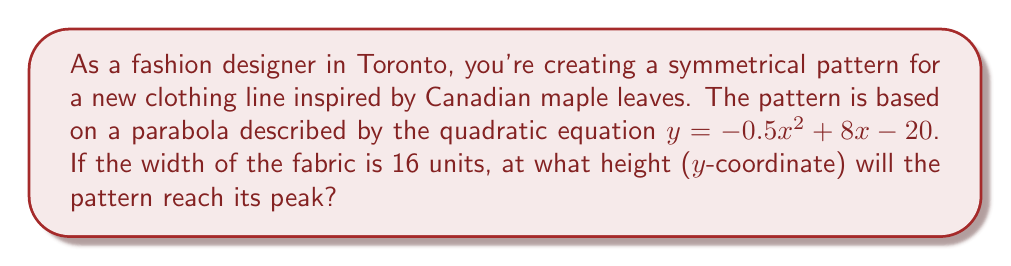Provide a solution to this math problem. To find the peak of the parabola, we need to follow these steps:

1) The quadratic equation is in the form $y = ax^2 + bx + c$, where:
   $a = -0.5$
   $b = 8$
   $c = -20$

2) For a parabola $y = ax^2 + bx + c$, the x-coordinate of the vertex is given by the formula:
   $$x = -\frac{b}{2a}$$

3) Substituting our values:
   $$x = -\frac{8}{2(-0.5)} = -\frac{8}{-1} = 8$$

4) To find the y-coordinate (height) of the vertex, we substitute this x-value back into the original equation:

   $$\begin{align}
   y &= -0.5(8)^2 + 8(8) - 20 \\
   &= -0.5(64) + 64 - 20 \\
   &= -32 + 64 - 20 \\
   &= 12
   \end{align}$$

5) Therefore, the vertex of the parabola is at the point (8, 12).

This means the pattern will reach its peak height at y = 12 units.
Answer: The pattern will reach its peak at a height of 12 units. 